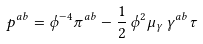Convert formula to latex. <formula><loc_0><loc_0><loc_500><loc_500>p ^ { a b } = \phi ^ { - 4 } \pi ^ { a b } - \frac { 1 } { 2 } \, \phi ^ { 2 } \mu _ { \gamma } \, \gamma ^ { a b } \tau</formula> 